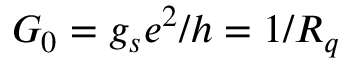Convert formula to latex. <formula><loc_0><loc_0><loc_500><loc_500>G _ { 0 } = g _ { s } e ^ { 2 } / h = 1 / R _ { q }</formula> 